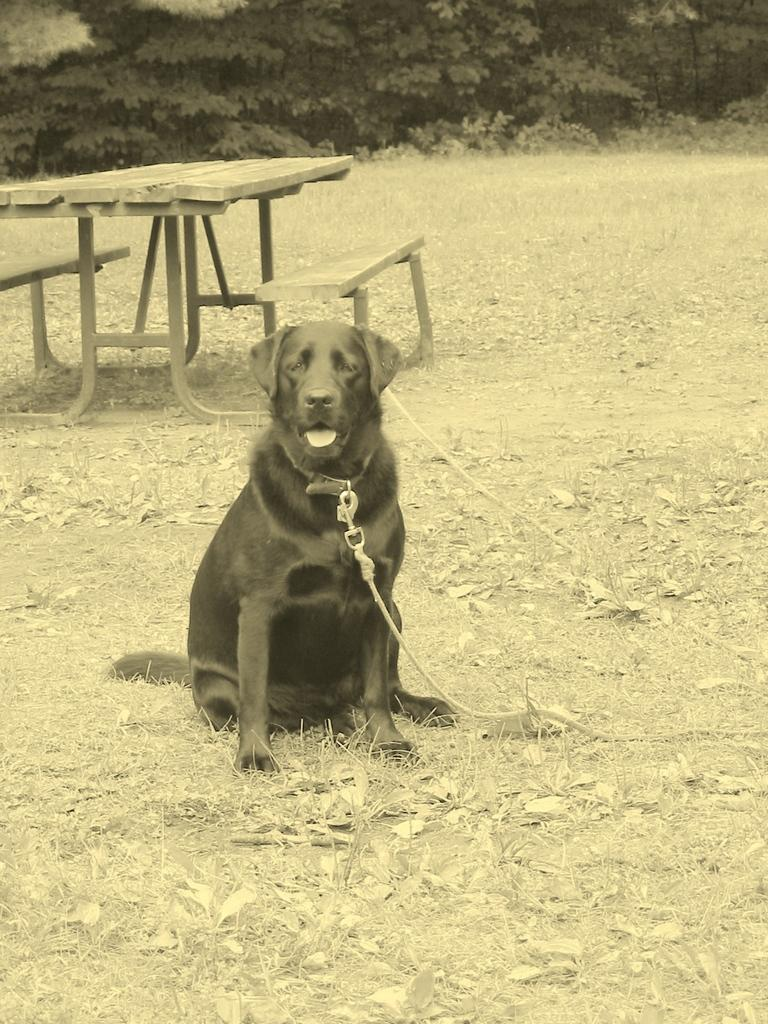What type of animal is in the image? There is a dog in the image. Where is the dog located? The dog is on the grass. What can be seen in the background of the image? There is a wooden table in the background of the image. What type of car is visible in the image? There is no car present in the image. How many legs does the dog have in the image? The dog has four legs in the image. What type of jelly can be seen in the image? There is no jelly present in the image. 